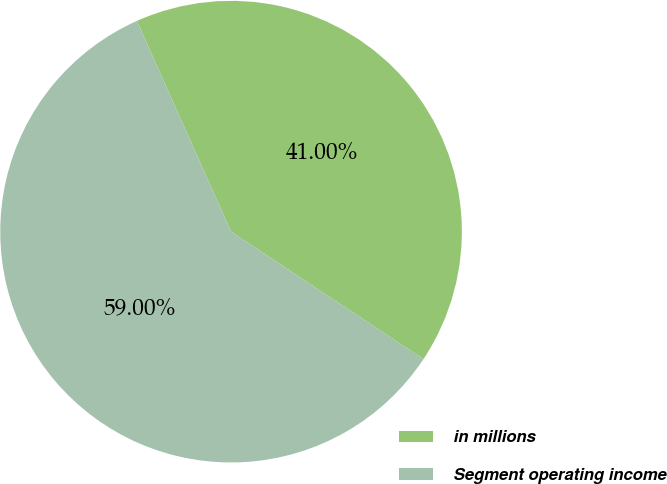<chart> <loc_0><loc_0><loc_500><loc_500><pie_chart><fcel>in millions<fcel>Segment operating income<nl><fcel>41.0%<fcel>59.0%<nl></chart> 